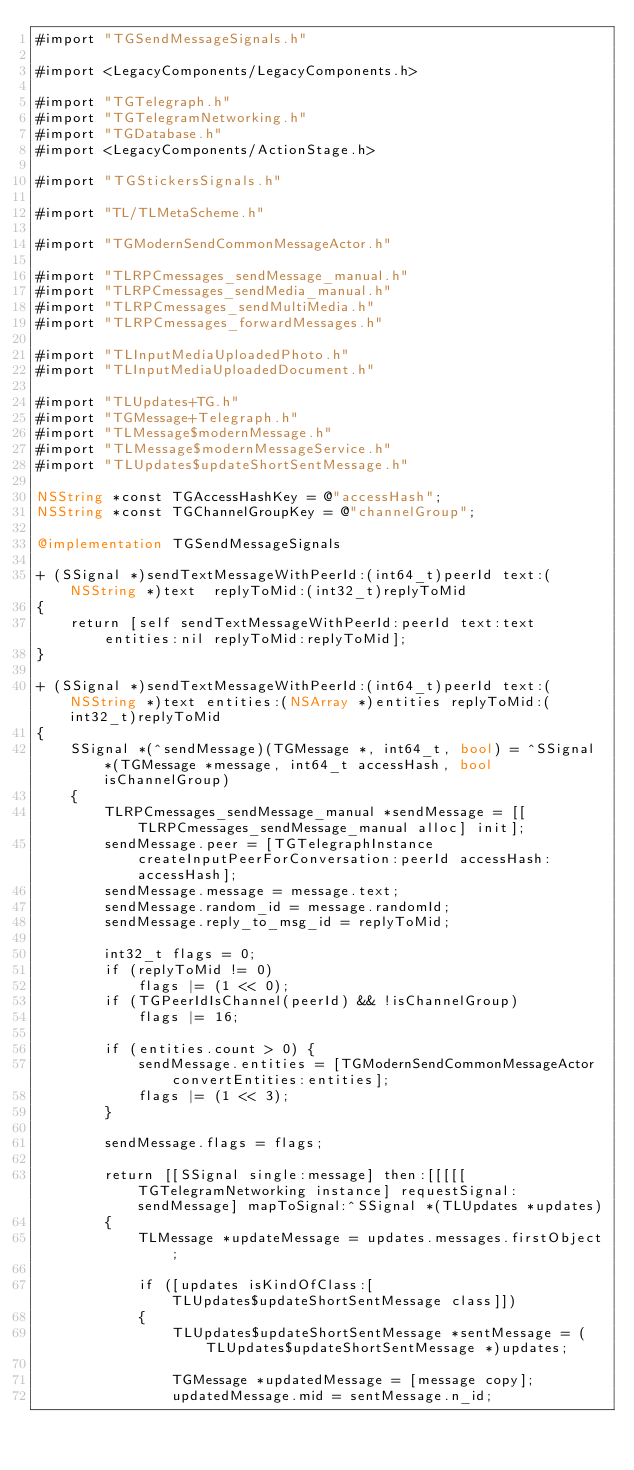<code> <loc_0><loc_0><loc_500><loc_500><_ObjectiveC_>#import "TGSendMessageSignals.h"

#import <LegacyComponents/LegacyComponents.h>

#import "TGTelegraph.h"
#import "TGTelegramNetworking.h"
#import "TGDatabase.h"
#import <LegacyComponents/ActionStage.h>

#import "TGStickersSignals.h"

#import "TL/TLMetaScheme.h"

#import "TGModernSendCommonMessageActor.h"

#import "TLRPCmessages_sendMessage_manual.h"
#import "TLRPCmessages_sendMedia_manual.h"
#import "TLRPCmessages_sendMultiMedia.h"
#import "TLRPCmessages_forwardMessages.h"

#import "TLInputMediaUploadedPhoto.h"
#import "TLInputMediaUploadedDocument.h"

#import "TLUpdates+TG.h"
#import "TGMessage+Telegraph.h"
#import "TLMessage$modernMessage.h"
#import "TLMessage$modernMessageService.h"
#import "TLUpdates$updateShortSentMessage.h"

NSString *const TGAccessHashKey = @"accessHash";
NSString *const TGChannelGroupKey = @"channelGroup";

@implementation TGSendMessageSignals

+ (SSignal *)sendTextMessageWithPeerId:(int64_t)peerId text:(NSString *)text  replyToMid:(int32_t)replyToMid
{
    return [self sendTextMessageWithPeerId:peerId text:text entities:nil replyToMid:replyToMid];
}

+ (SSignal *)sendTextMessageWithPeerId:(int64_t)peerId text:(NSString *)text entities:(NSArray *)entities replyToMid:(int32_t)replyToMid
{
    SSignal *(^sendMessage)(TGMessage *, int64_t, bool) = ^SSignal *(TGMessage *message, int64_t accessHash, bool isChannelGroup)
    {
        TLRPCmessages_sendMessage_manual *sendMessage = [[TLRPCmessages_sendMessage_manual alloc] init];
        sendMessage.peer = [TGTelegraphInstance createInputPeerForConversation:peerId accessHash:accessHash];
        sendMessage.message = message.text;
        sendMessage.random_id = message.randomId;
        sendMessage.reply_to_msg_id = replyToMid;
        
        int32_t flags = 0;
        if (replyToMid != 0)
            flags |= (1 << 0);
        if (TGPeerIdIsChannel(peerId) && !isChannelGroup)
            flags |= 16;
        
        if (entities.count > 0) {
            sendMessage.entities = [TGModernSendCommonMessageActor convertEntities:entities];
            flags |= (1 << 3);
        }
        
        sendMessage.flags = flags;
        
        return [[SSignal single:message] then:[[[[[TGTelegramNetworking instance] requestSignal:sendMessage] mapToSignal:^SSignal *(TLUpdates *updates)
        {
            TLMessage *updateMessage = updates.messages.firstObject;
            
            if ([updates isKindOfClass:[TLUpdates$updateShortSentMessage class]])
            {
                TLUpdates$updateShortSentMessage *sentMessage = (TLUpdates$updateShortSentMessage *)updates;
                
                TGMessage *updatedMessage = [message copy];
                updatedMessage.mid = sentMessage.n_id;</code> 